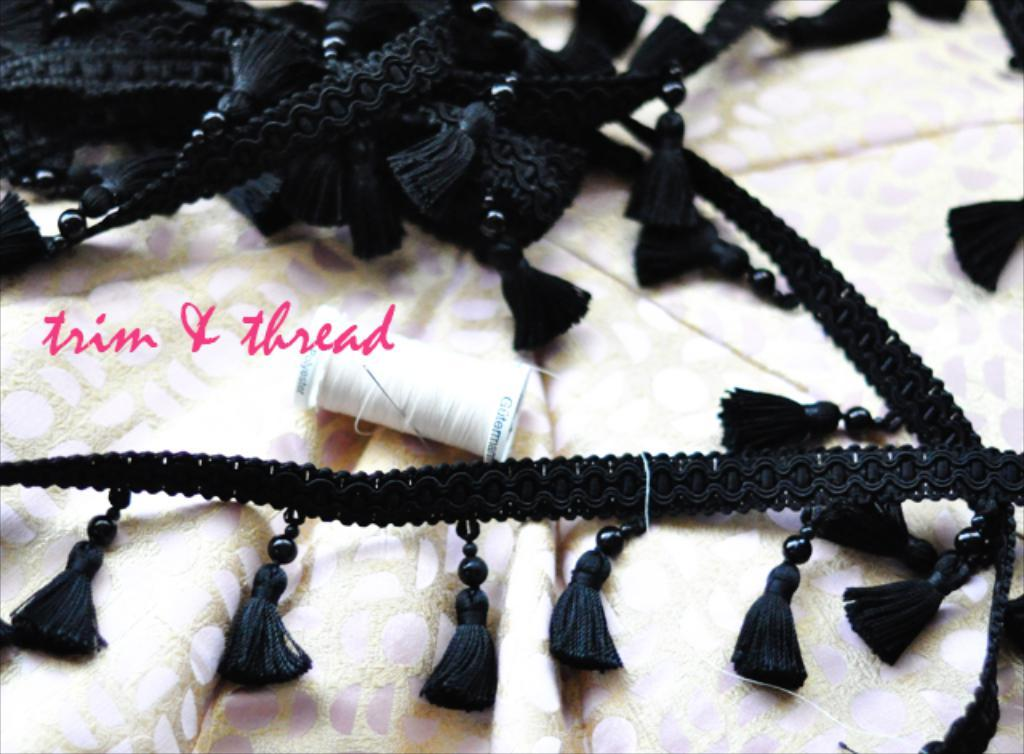What color is the cloth that is visible in the image? There is a black colored cloth in the image. What other items can be seen in the image related to sewing? There is a thread bundle and a needle in the image. What is the color of the cloth on which the needle is placed? The needle is on a cream and pink colored cloth. Is there any text present in the image? Yes, there is text written on the image. Can you see a kitty playing with the needle in the image? There is no kitty present in the image, and therefore no such activity can be observed. 